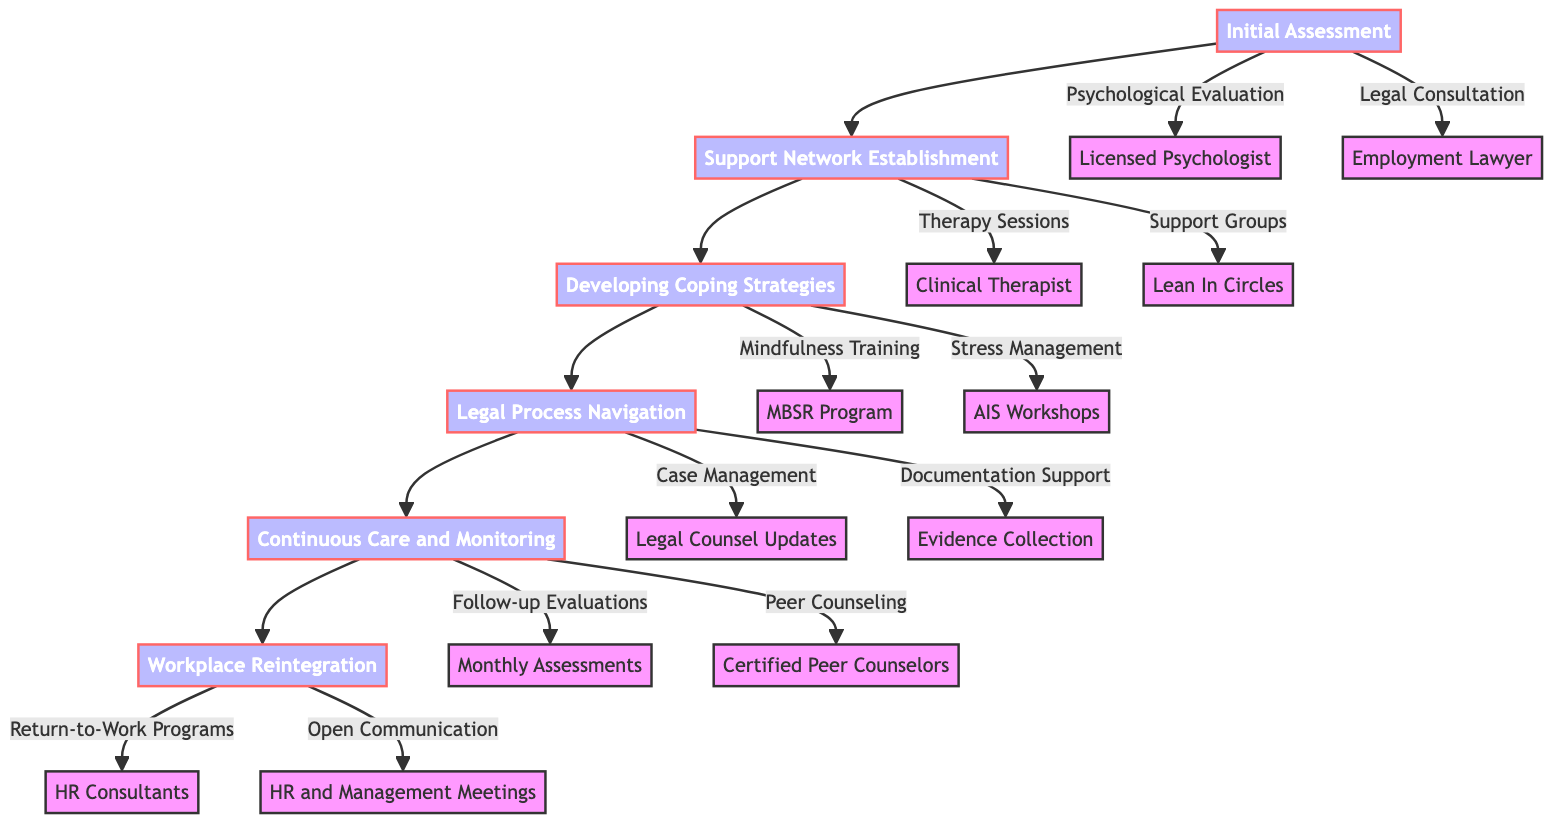What are the two main components of the Initial Assessment? The Initial Assessment comprises "Psychological Evaluation" and "Legal Consultation." These components can be found as the first set of nodes branching from the main node "Initial Assessment."
Answer: Psychological Evaluation, Legal Consultation How many phases are there in the Clinical Pathway? The diagram consists of six main phases, indicated by the flow from "Initial Assessment" to "Workplace Reintegration." Each phase represents a step in the pathway.
Answer: 6 What type of support can be found under "Support Network Establishment"? Under "Support Network Establishment," there are "Therapy Sessions" with a clinical therapist and "Support Groups," specifically "Lean In Circles." These details appear as nodes connected to "Support Network Establishment."
Answer: Therapy Sessions, Support Groups What is included in the Developing Coping Strategies phase? The Developing Coping Strategies phase includes "Mindfulness Training" and "Stress Management." Both strategies are represented as nodes stemming from this phase.
Answer: Mindfulness Training, Stress Management Which phase includes assistance with documenting experiences? The phase "Legal Process Navigation" includes "Documentation Support," which provides assistance with documenting experiences and evidence collection. This can be found as a sub-node under "Legal Process Navigation."
Answer: Legal Process Navigation What does Continuous Care and Monitoring consist of? "Continuous Care and Monitoring" comprises "Follow-up Psychological Evaluations" and "Peer Counseling," both of which are listed as components under this phase of the pathway.
Answer: Follow-up Psychological Evaluations, Peer Counseling How are the elements of Workplace Reintegration structured? The elements of "Workplace Reintegration" are structured into "Return-to-Work Programs" and "Open Communication Channels," which are illustrated as nodes branching from this phase.
Answer: Return-to-Work Programs, Open Communication Channels What type of lawyer is consulted during the Initial Assessment? During the Initial Assessment, the type of lawyer consulted is specifically an "Employment Lawyer" who specializes in discrimination cases. This is indicated directly from the "Legal Consultation" node.
Answer: Employment Lawyer What entails regular updates within the Legal Process Navigation? "Case Management" entails regular updates, specifically indicating consistent communication and check-ins with legal counsel throughout the legal process. This concept is represented as a node under "Legal Process Navigation."
Answer: Case Management 